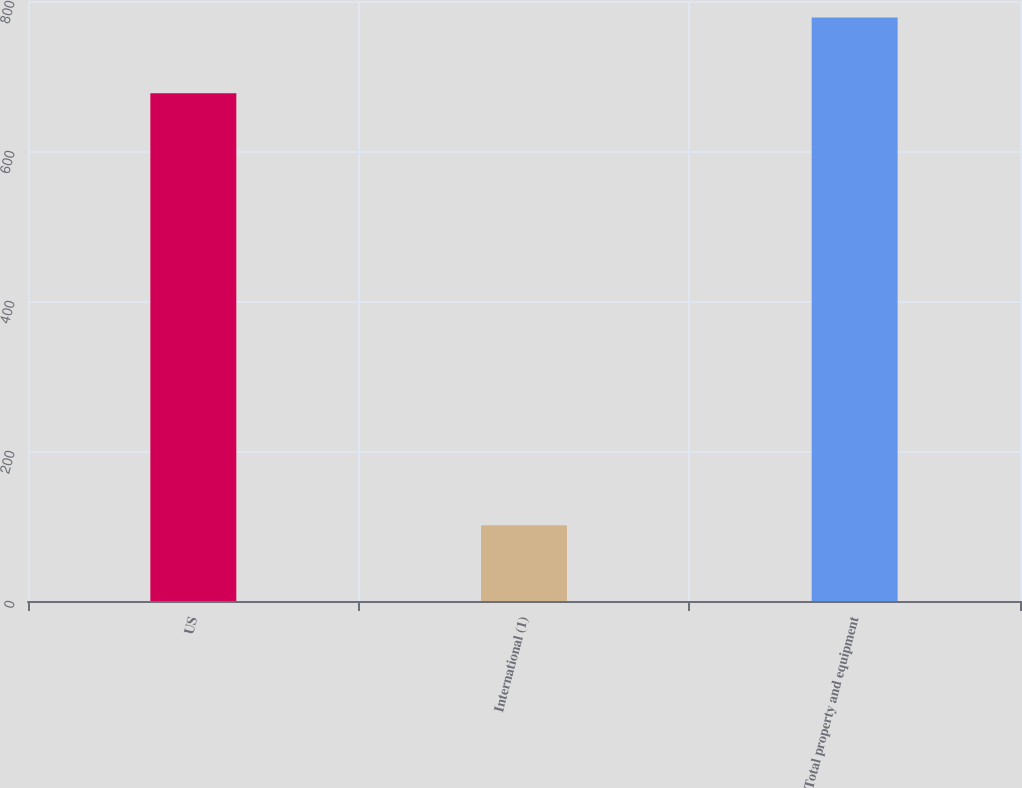<chart> <loc_0><loc_0><loc_500><loc_500><bar_chart><fcel>US<fcel>International (1)<fcel>Total property and equipment<nl><fcel>677<fcel>101<fcel>778<nl></chart> 